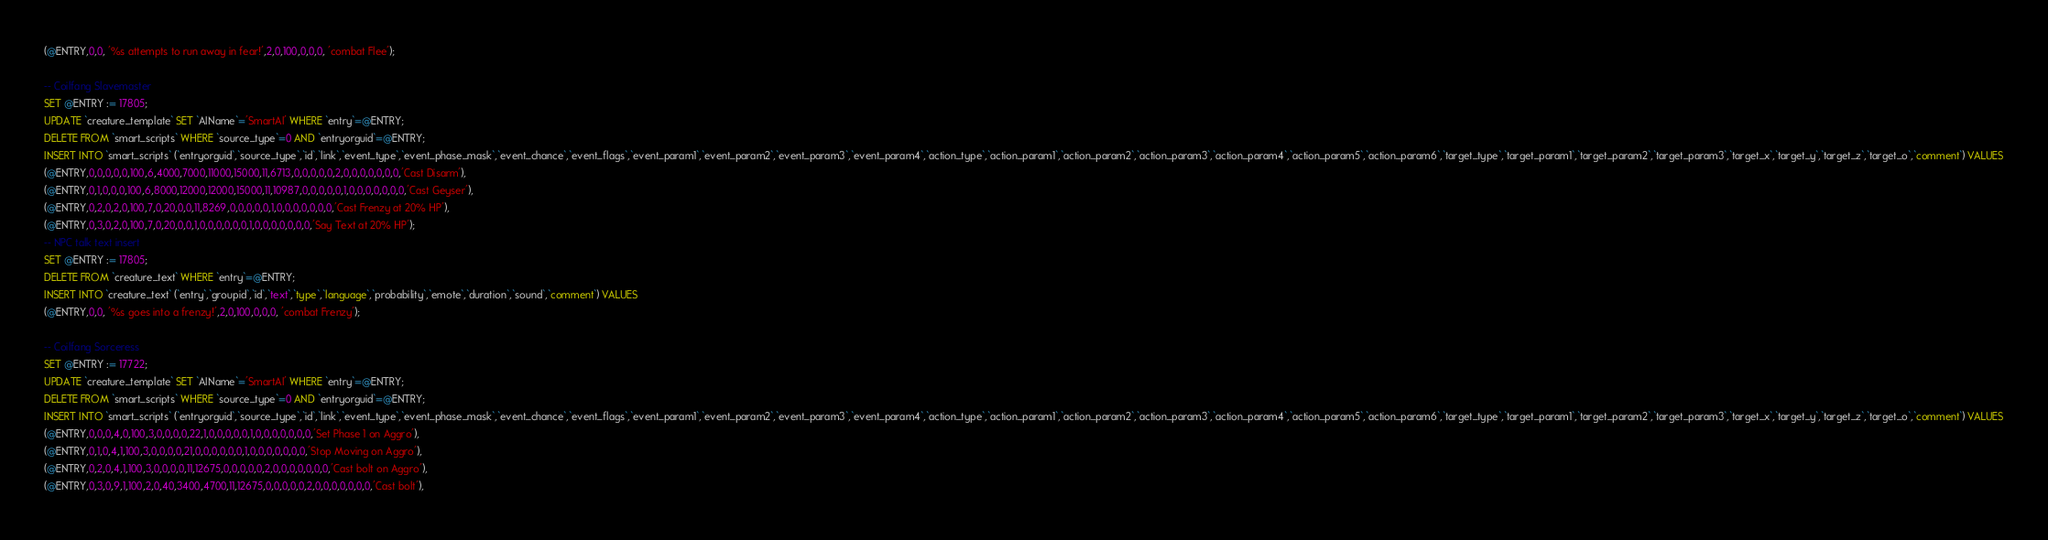Convert code to text. <code><loc_0><loc_0><loc_500><loc_500><_SQL_>(@ENTRY,0,0, '%s attempts to run away in fear!',2,0,100,0,0,0, 'combat Flee');

-- Coilfang Slavemaster
SET @ENTRY := 17805;
UPDATE `creature_template` SET `AIName`='SmartAI' WHERE `entry`=@ENTRY;
DELETE FROM `smart_scripts` WHERE `source_type`=0 AND `entryorguid`=@ENTRY;
INSERT INTO `smart_scripts` (`entryorguid`,`source_type`,`id`,`link`,`event_type`,`event_phase_mask`,`event_chance`,`event_flags`,`event_param1`,`event_param2`,`event_param3`,`event_param4`,`action_type`,`action_param1`,`action_param2`,`action_param3`,`action_param4`,`action_param5`,`action_param6`,`target_type`,`target_param1`,`target_param2`,`target_param3`,`target_x`,`target_y`,`target_z`,`target_o`,`comment`) VALUES
(@ENTRY,0,0,0,0,0,100,6,4000,7000,11000,15000,11,6713,0,0,0,0,0,2,0,0,0,0,0,0,0,'Cast Disarm'),
(@ENTRY,0,1,0,0,0,100,6,8000,12000,12000,15000,11,10987,0,0,0,0,0,1,0,0,0,0,0,0,0,'Cast Geyser'),
(@ENTRY,0,2,0,2,0,100,7,0,20,0,0,11,8269,0,0,0,0,0,1,0,0,0,0,0,0,0,'Cast Frenzy at 20% HP'),
(@ENTRY,0,3,0,2,0,100,7,0,20,0,0,1,0,0,0,0,0,0,1,0,0,0,0,0,0,0,'Say Text at 20% HP');
-- NPC talk text insert
SET @ENTRY := 17805;
DELETE FROM `creature_text` WHERE `entry`=@ENTRY;
INSERT INTO `creature_text` (`entry`,`groupid`,`id`,`text`,`type`,`language`,`probability`,`emote`,`duration`,`sound`,`comment`) VALUES
(@ENTRY,0,0, '%s goes into a frenzy!',2,0,100,0,0,0, 'combat Frenzy');

-- Coilfang Sorceress
SET @ENTRY := 17722;
UPDATE `creature_template` SET `AIName`='SmartAI' WHERE `entry`=@ENTRY;
DELETE FROM `smart_scripts` WHERE `source_type`=0 AND `entryorguid`=@ENTRY;
INSERT INTO `smart_scripts` (`entryorguid`,`source_type`,`id`,`link`,`event_type`,`event_phase_mask`,`event_chance`,`event_flags`,`event_param1`,`event_param2`,`event_param3`,`event_param4`,`action_type`,`action_param1`,`action_param2`,`action_param3`,`action_param4`,`action_param5`,`action_param6`,`target_type`,`target_param1`,`target_param2`,`target_param3`,`target_x`,`target_y`,`target_z`,`target_o`,`comment`) VALUES
(@ENTRY,0,0,0,4,0,100,3,0,0,0,0,22,1,0,0,0,0,0,1,0,0,0,0,0,0,0,'Set Phase 1 on Aggro'),
(@ENTRY,0,1,0,4,1,100,3,0,0,0,0,21,0,0,0,0,0,0,1,0,0,0,0,0,0,0,'Stop Moving on Aggro'),
(@ENTRY,0,2,0,4,1,100,3,0,0,0,0,11,12675,0,0,0,0,0,2,0,0,0,0,0,0,0,'Cast bolt on Aggro'),
(@ENTRY,0,3,0,9,1,100,2,0,40,3400,4700,11,12675,0,0,0,0,0,2,0,0,0,0,0,0,0,'Cast bolt'),</code> 